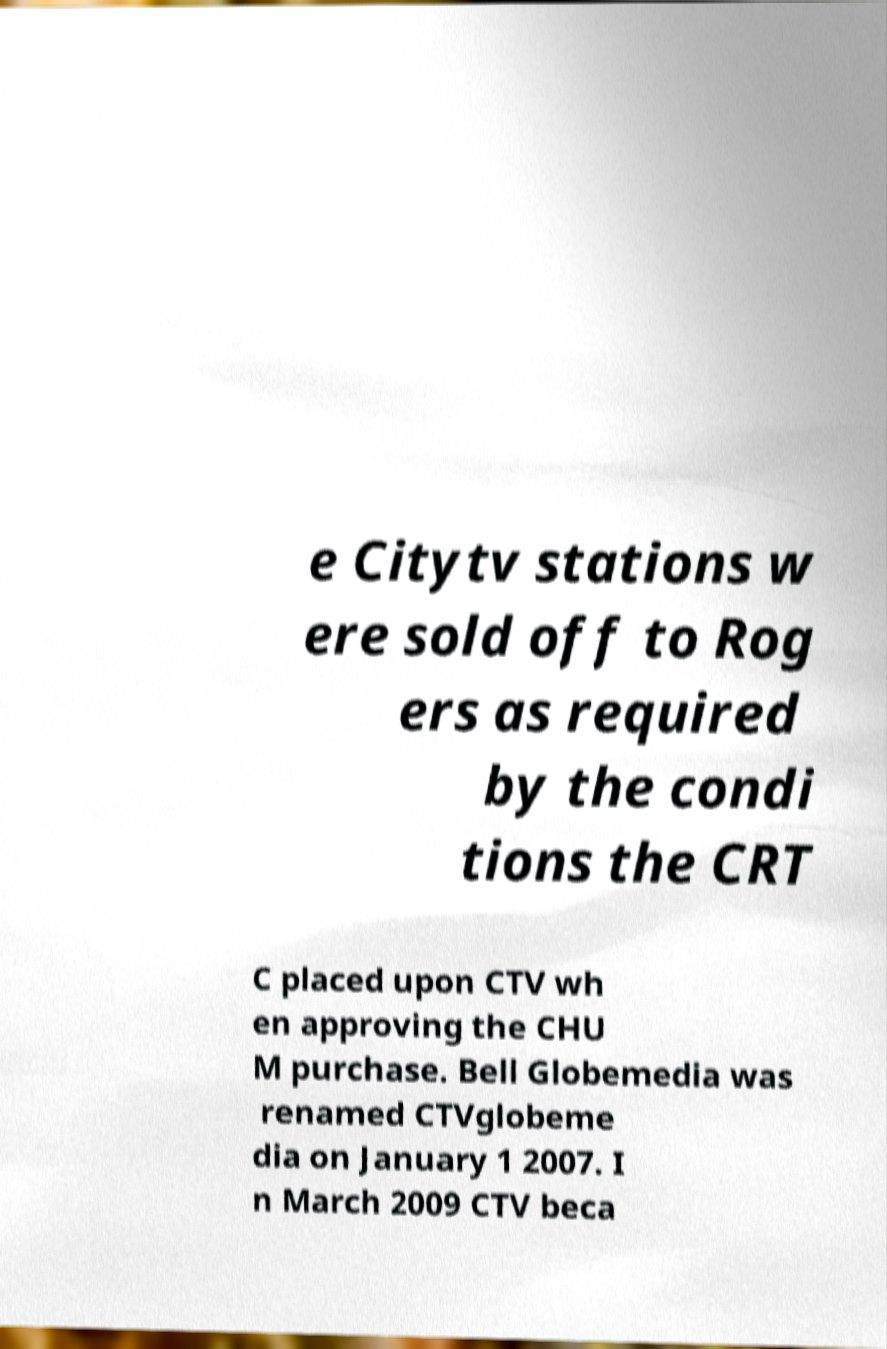Can you accurately transcribe the text from the provided image for me? e Citytv stations w ere sold off to Rog ers as required by the condi tions the CRT C placed upon CTV wh en approving the CHU M purchase. Bell Globemedia was renamed CTVglobeme dia on January 1 2007. I n March 2009 CTV beca 